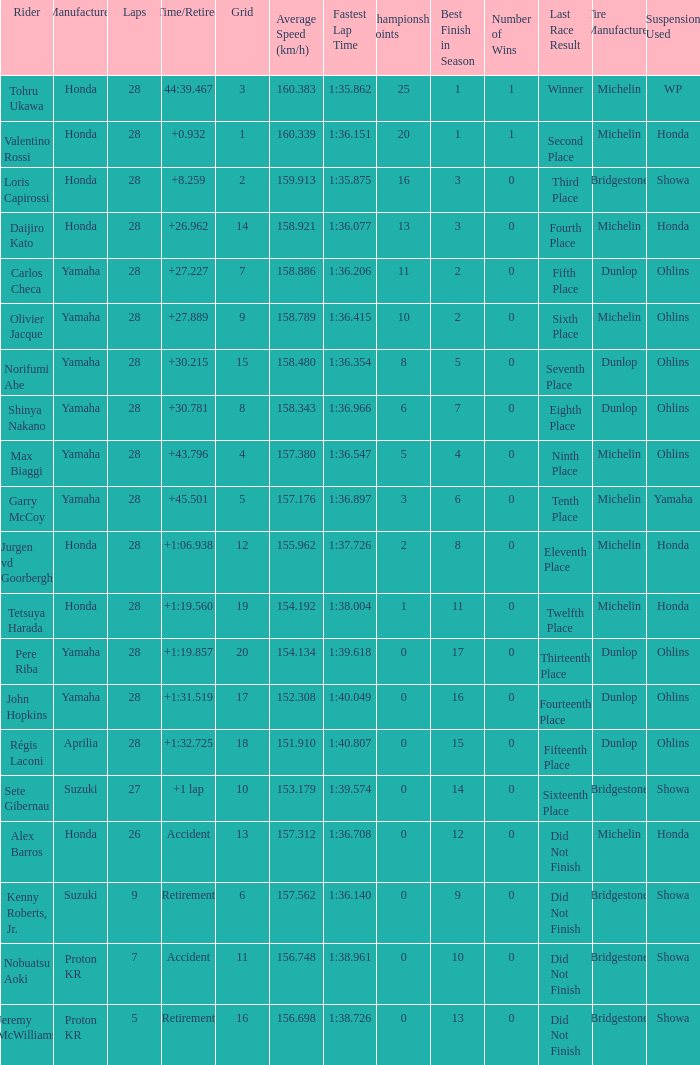Parse the table in full. {'header': ['Rider', 'Manufacturer', 'Laps', 'Time/Retired', 'Grid', 'Average Speed (km/h)', 'Fastest Lap Time', 'Championship Points', 'Best Finish in Season', 'Number of Wins', 'Last Race Result', 'Tire Manufacturer', 'Suspension Used '], 'rows': [['Tohru Ukawa', 'Honda', '28', '44:39.467', '3', '160.383', '1:35.862', '25', '1', '1', 'Winner', 'Michelin', 'WP'], ['Valentino Rossi', 'Honda', '28', '+0.932', '1', '160.339', '1:36.151', '20', '1', '1', 'Second Place', 'Michelin', 'Honda'], ['Loris Capirossi', 'Honda', '28', '+8.259', '2', '159.913', '1:35.875', '16', '3', '0', 'Third Place', 'Bridgestone', 'Showa'], ['Daijiro Kato', 'Honda', '28', '+26.962', '14', '158.921', '1:36.077', '13', '3', '0', 'Fourth Place', 'Michelin', 'Honda'], ['Carlos Checa', 'Yamaha', '28', '+27.227', '7', '158.886', '1:36.206', '11', '2', '0', 'Fifth Place', 'Dunlop', 'Ohlins'], ['Olivier Jacque', 'Yamaha', '28', '+27.889', '9', '158.789', '1:36.415', '10', '2', '0', 'Sixth Place', 'Michelin', 'Ohlins'], ['Norifumi Abe', 'Yamaha', '28', '+30.215', '15', '158.480', '1:36.354', '8', '5', '0', 'Seventh Place', 'Dunlop', 'Ohlins'], ['Shinya Nakano', 'Yamaha', '28', '+30.781', '8', '158.343', '1:36.966', '6', '7', '0', 'Eighth Place', 'Dunlop', 'Ohlins'], ['Max Biaggi', 'Yamaha', '28', '+43.796', '4', '157.380', '1:36.547', '5', '4', '0', 'Ninth Place', 'Michelin', 'Ohlins'], ['Garry McCoy', 'Yamaha', '28', '+45.501', '5', '157.176', '1:36.897', '3', '6', '0', 'Tenth Place', 'Michelin', 'Yamaha'], ['Jurgen vd Goorbergh', 'Honda', '28', '+1:06.938', '12', '155.962', '1:37.726', '2', '8', '0', 'Eleventh Place', 'Michelin', 'Honda'], ['Tetsuya Harada', 'Honda', '28', '+1:19.560', '19', '154.192', '1:38.004', '1', '11', '0', 'Twelfth Place', 'Michelin', 'Honda'], ['Pere Riba', 'Yamaha', '28', '+1:19.857', '20', '154.134', '1:39.618', '0', '17', '0', 'Thirteenth Place', 'Dunlop', 'Ohlins'], ['John Hopkins', 'Yamaha', '28', '+1:31.519', '17', '152.308', '1:40.049', '0', '16', '0', 'Fourteenth Place', 'Dunlop', 'Ohlins'], ['Régis Laconi', 'Aprilia', '28', '+1:32.725', '18', '151.910', '1:40.807', '0', '15', '0', 'Fifteenth Place', 'Dunlop', 'Ohlins'], ['Sete Gibernau', 'Suzuki', '27', '+1 lap', '10', '153.179', '1:39.574', '0', '14', '0', 'Sixteenth Place', 'Bridgestone', 'Showa'], ['Alex Barros', 'Honda', '26', 'Accident', '13', '157.312', '1:36.708', '0', '12', '0', 'Did Not Finish', 'Michelin', 'Honda'], ['Kenny Roberts, Jr.', 'Suzuki', '9', 'Retirement', '6', '157.562', '1:36.140', '0', '9', '0', 'Did Not Finish', 'Bridgestone', 'Showa'], ['Nobuatsu Aoki', 'Proton KR', '7', 'Accident', '11', '156.748', '1:38.961', '0', '10', '0', 'Did Not Finish', 'Bridgestone', 'Showa'], ['Jeremy McWilliams', 'Proton KR', '5', 'Retirement', '16', '156.698', '1:38.726', '0', '13', '0', 'Did Not Finish', 'Bridgestone', 'Showa']]} 467? 3.0. 